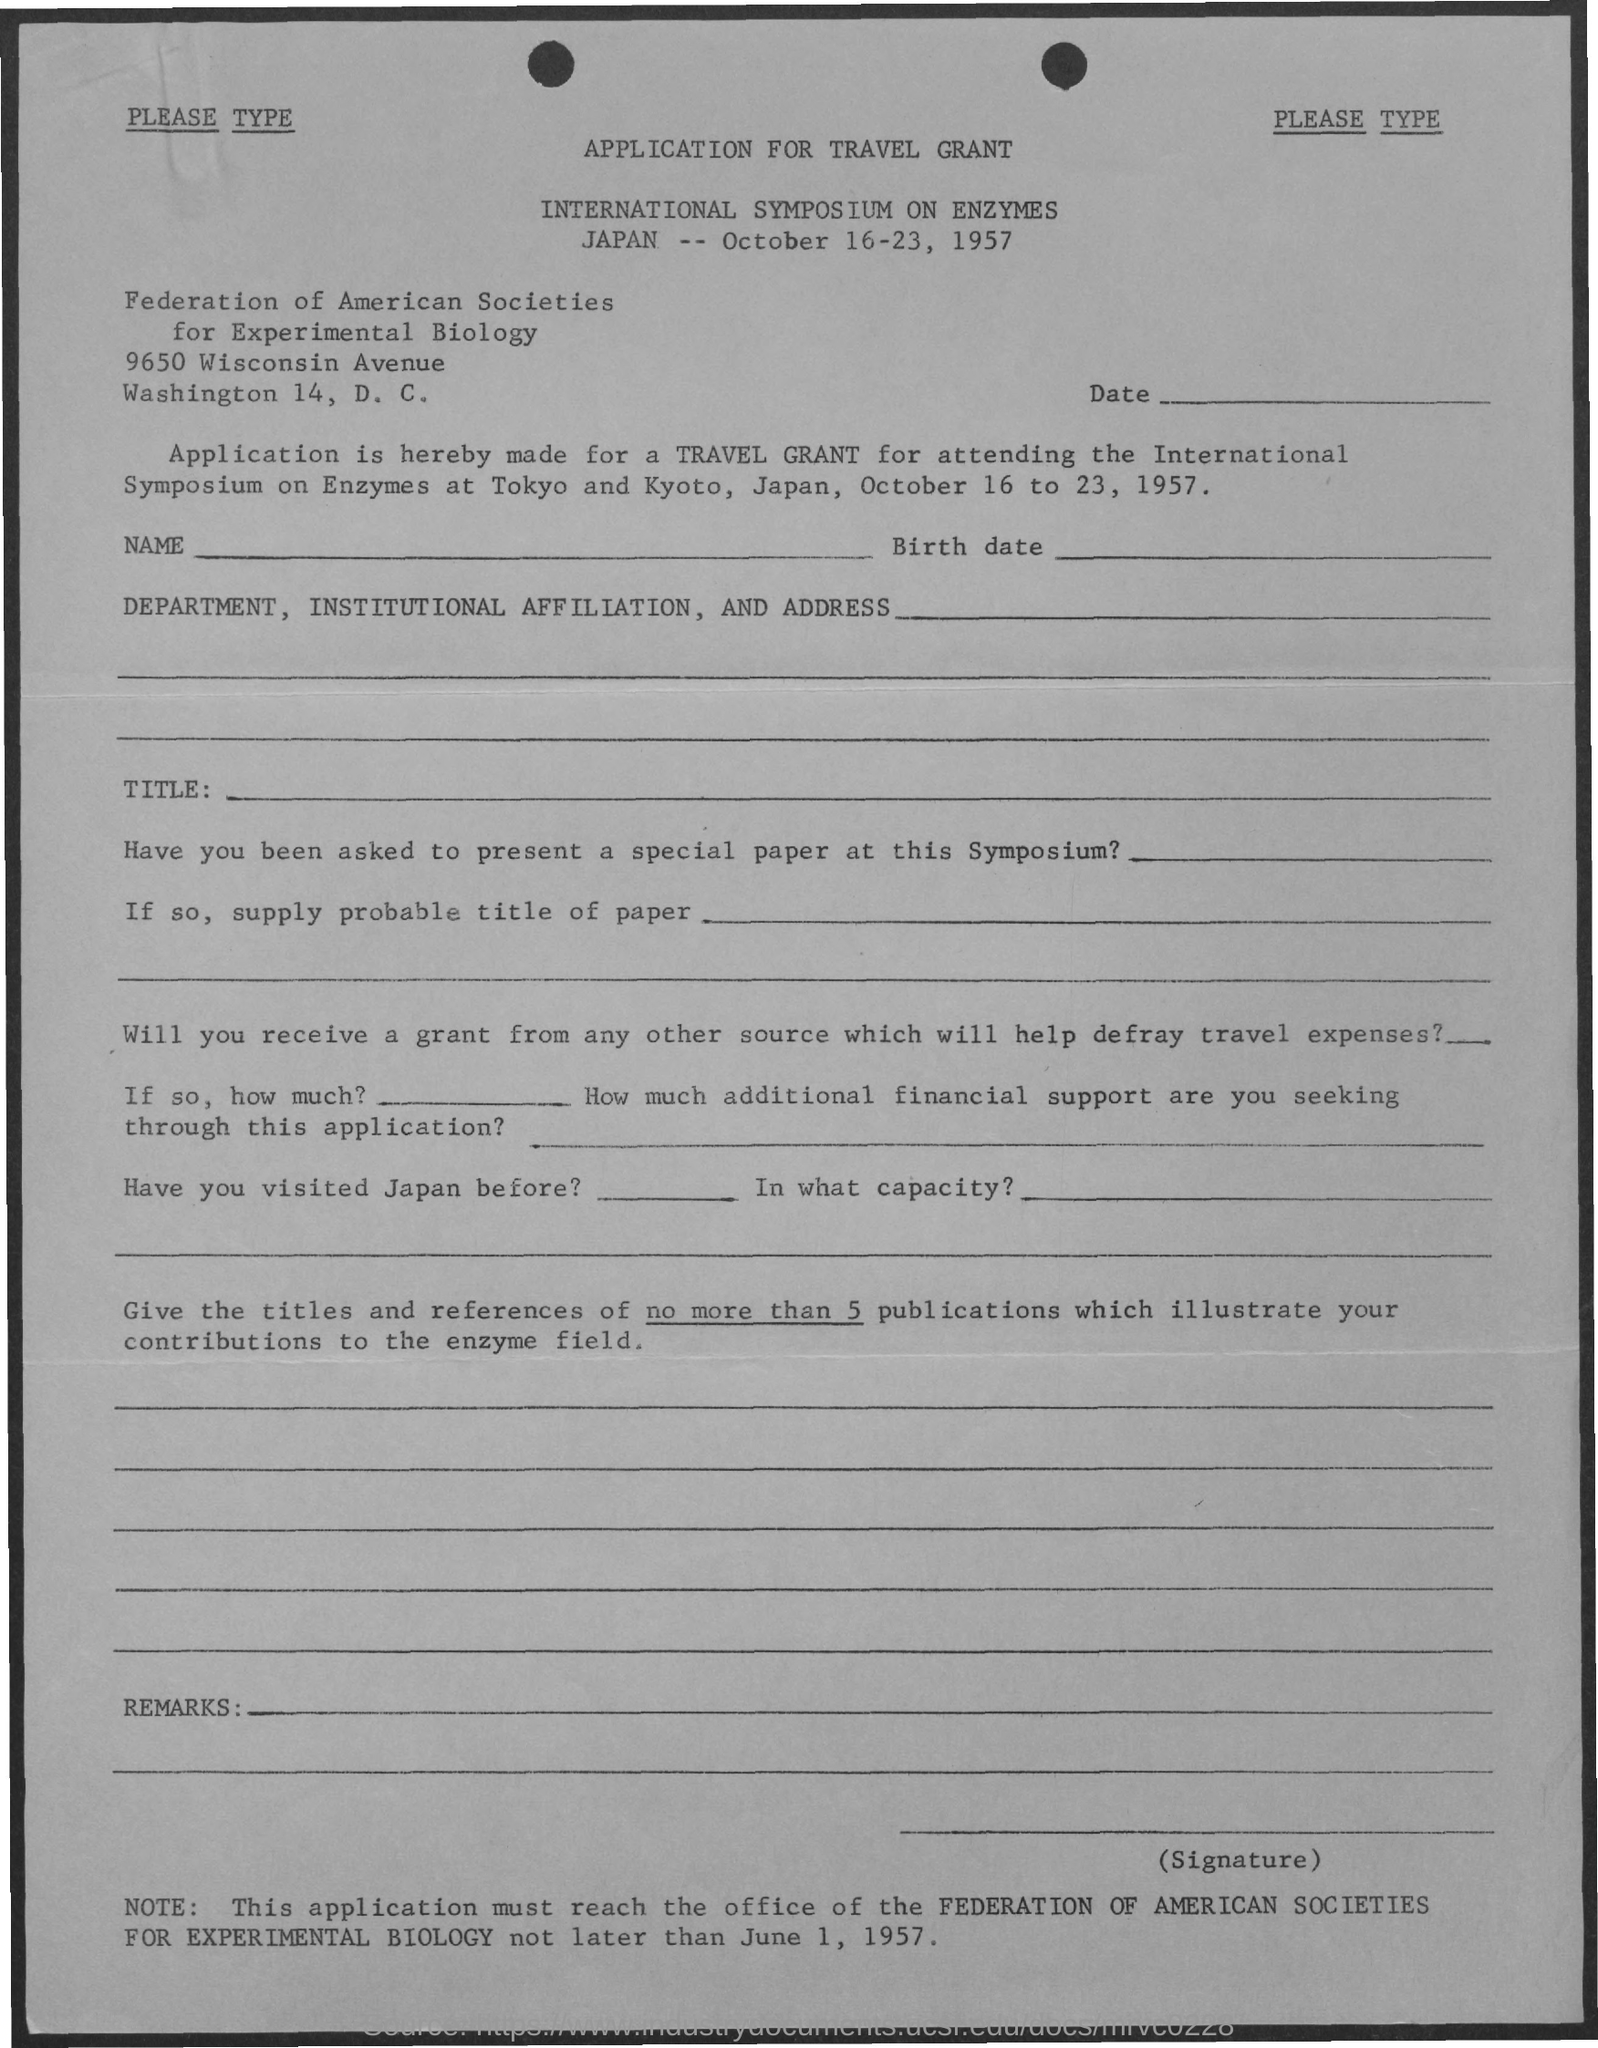List a handful of essential elements in this visual. It is mandatory that the application must be received by the office before June 1, 1957. 